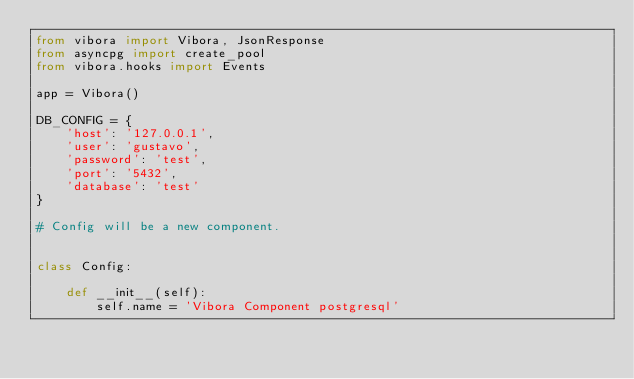<code> <loc_0><loc_0><loc_500><loc_500><_Python_>from vibora import Vibora, JsonResponse
from asyncpg import create_pool
from vibora.hooks import Events

app = Vibora()

DB_CONFIG = {
    'host': '127.0.0.1',
    'user': 'gustavo',
    'password': 'test',
    'port': '5432',
    'database': 'test'
}

# Config will be a new component.


class Config:

    def __init__(self):
        self.name = 'Vibora Component postgresql'
</code> 